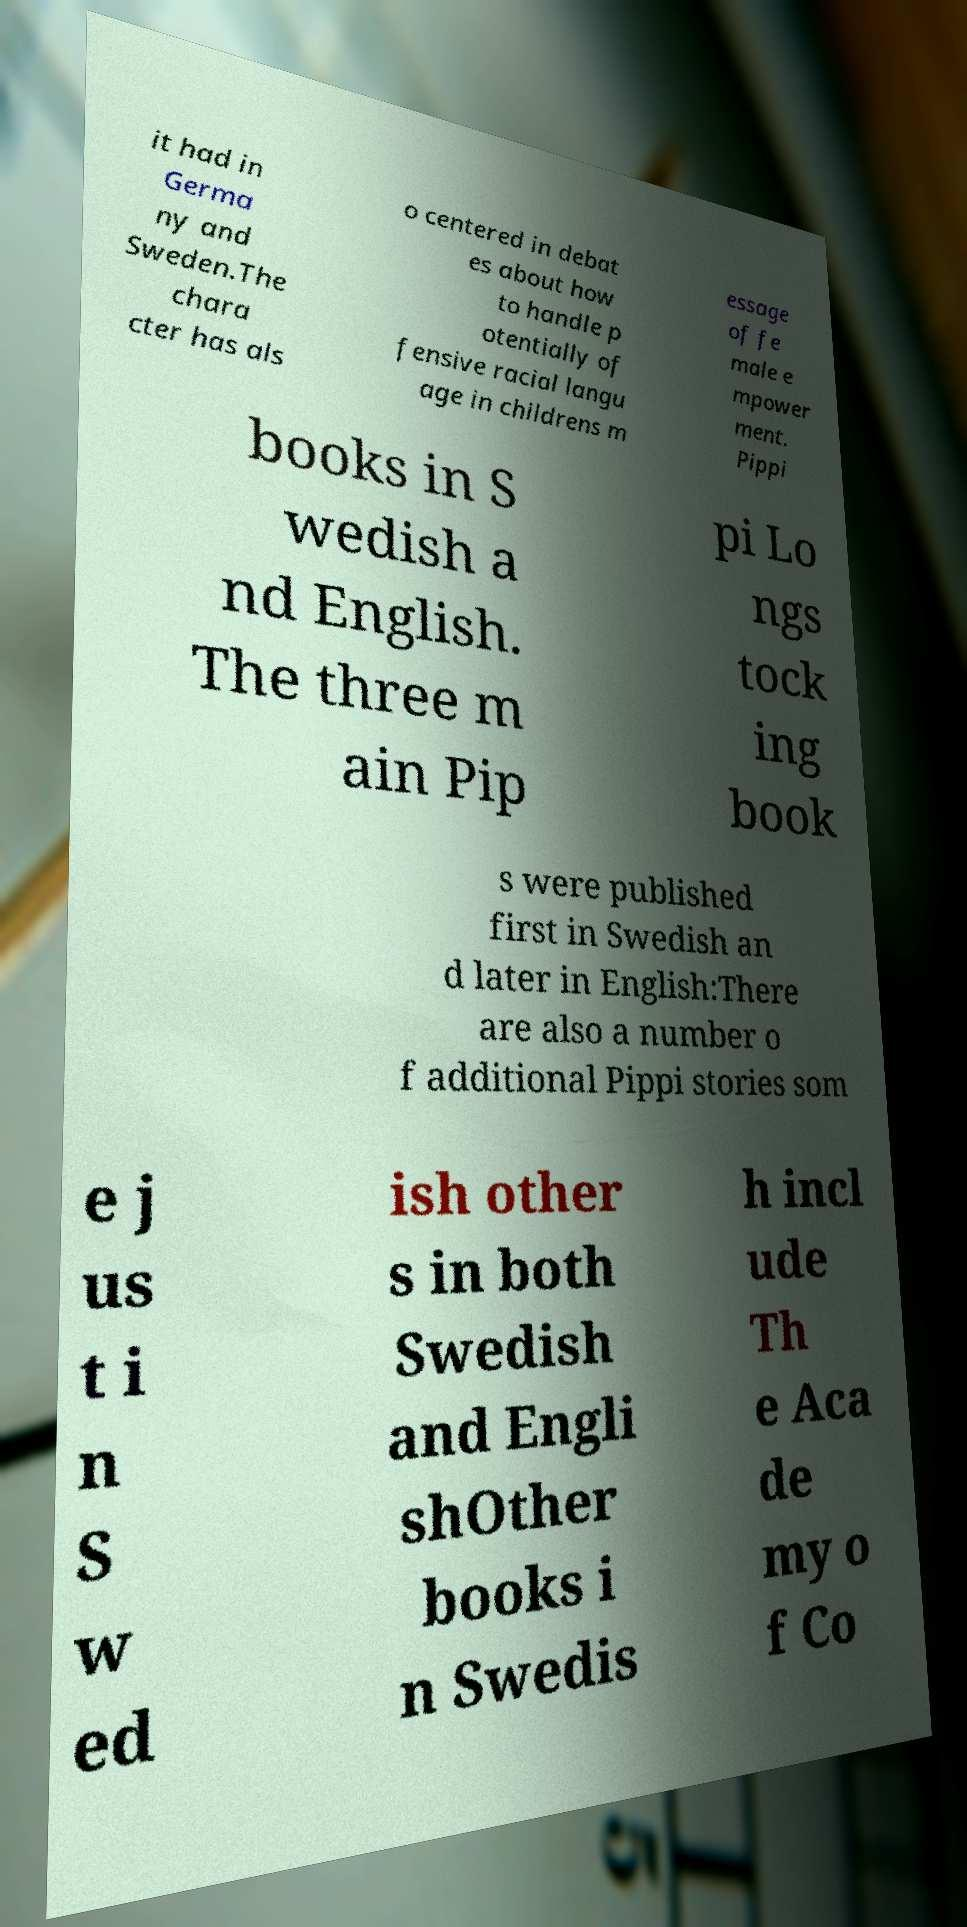What messages or text are displayed in this image? I need them in a readable, typed format. it had in Germa ny and Sweden.The chara cter has als o centered in debat es about how to handle p otentially of fensive racial langu age in childrens m essage of fe male e mpower ment. Pippi books in S wedish a nd English. The three m ain Pip pi Lo ngs tock ing book s were published first in Swedish an d later in English:There are also a number o f additional Pippi stories som e j us t i n S w ed ish other s in both Swedish and Engli shOther books i n Swedis h incl ude Th e Aca de my o f Co 